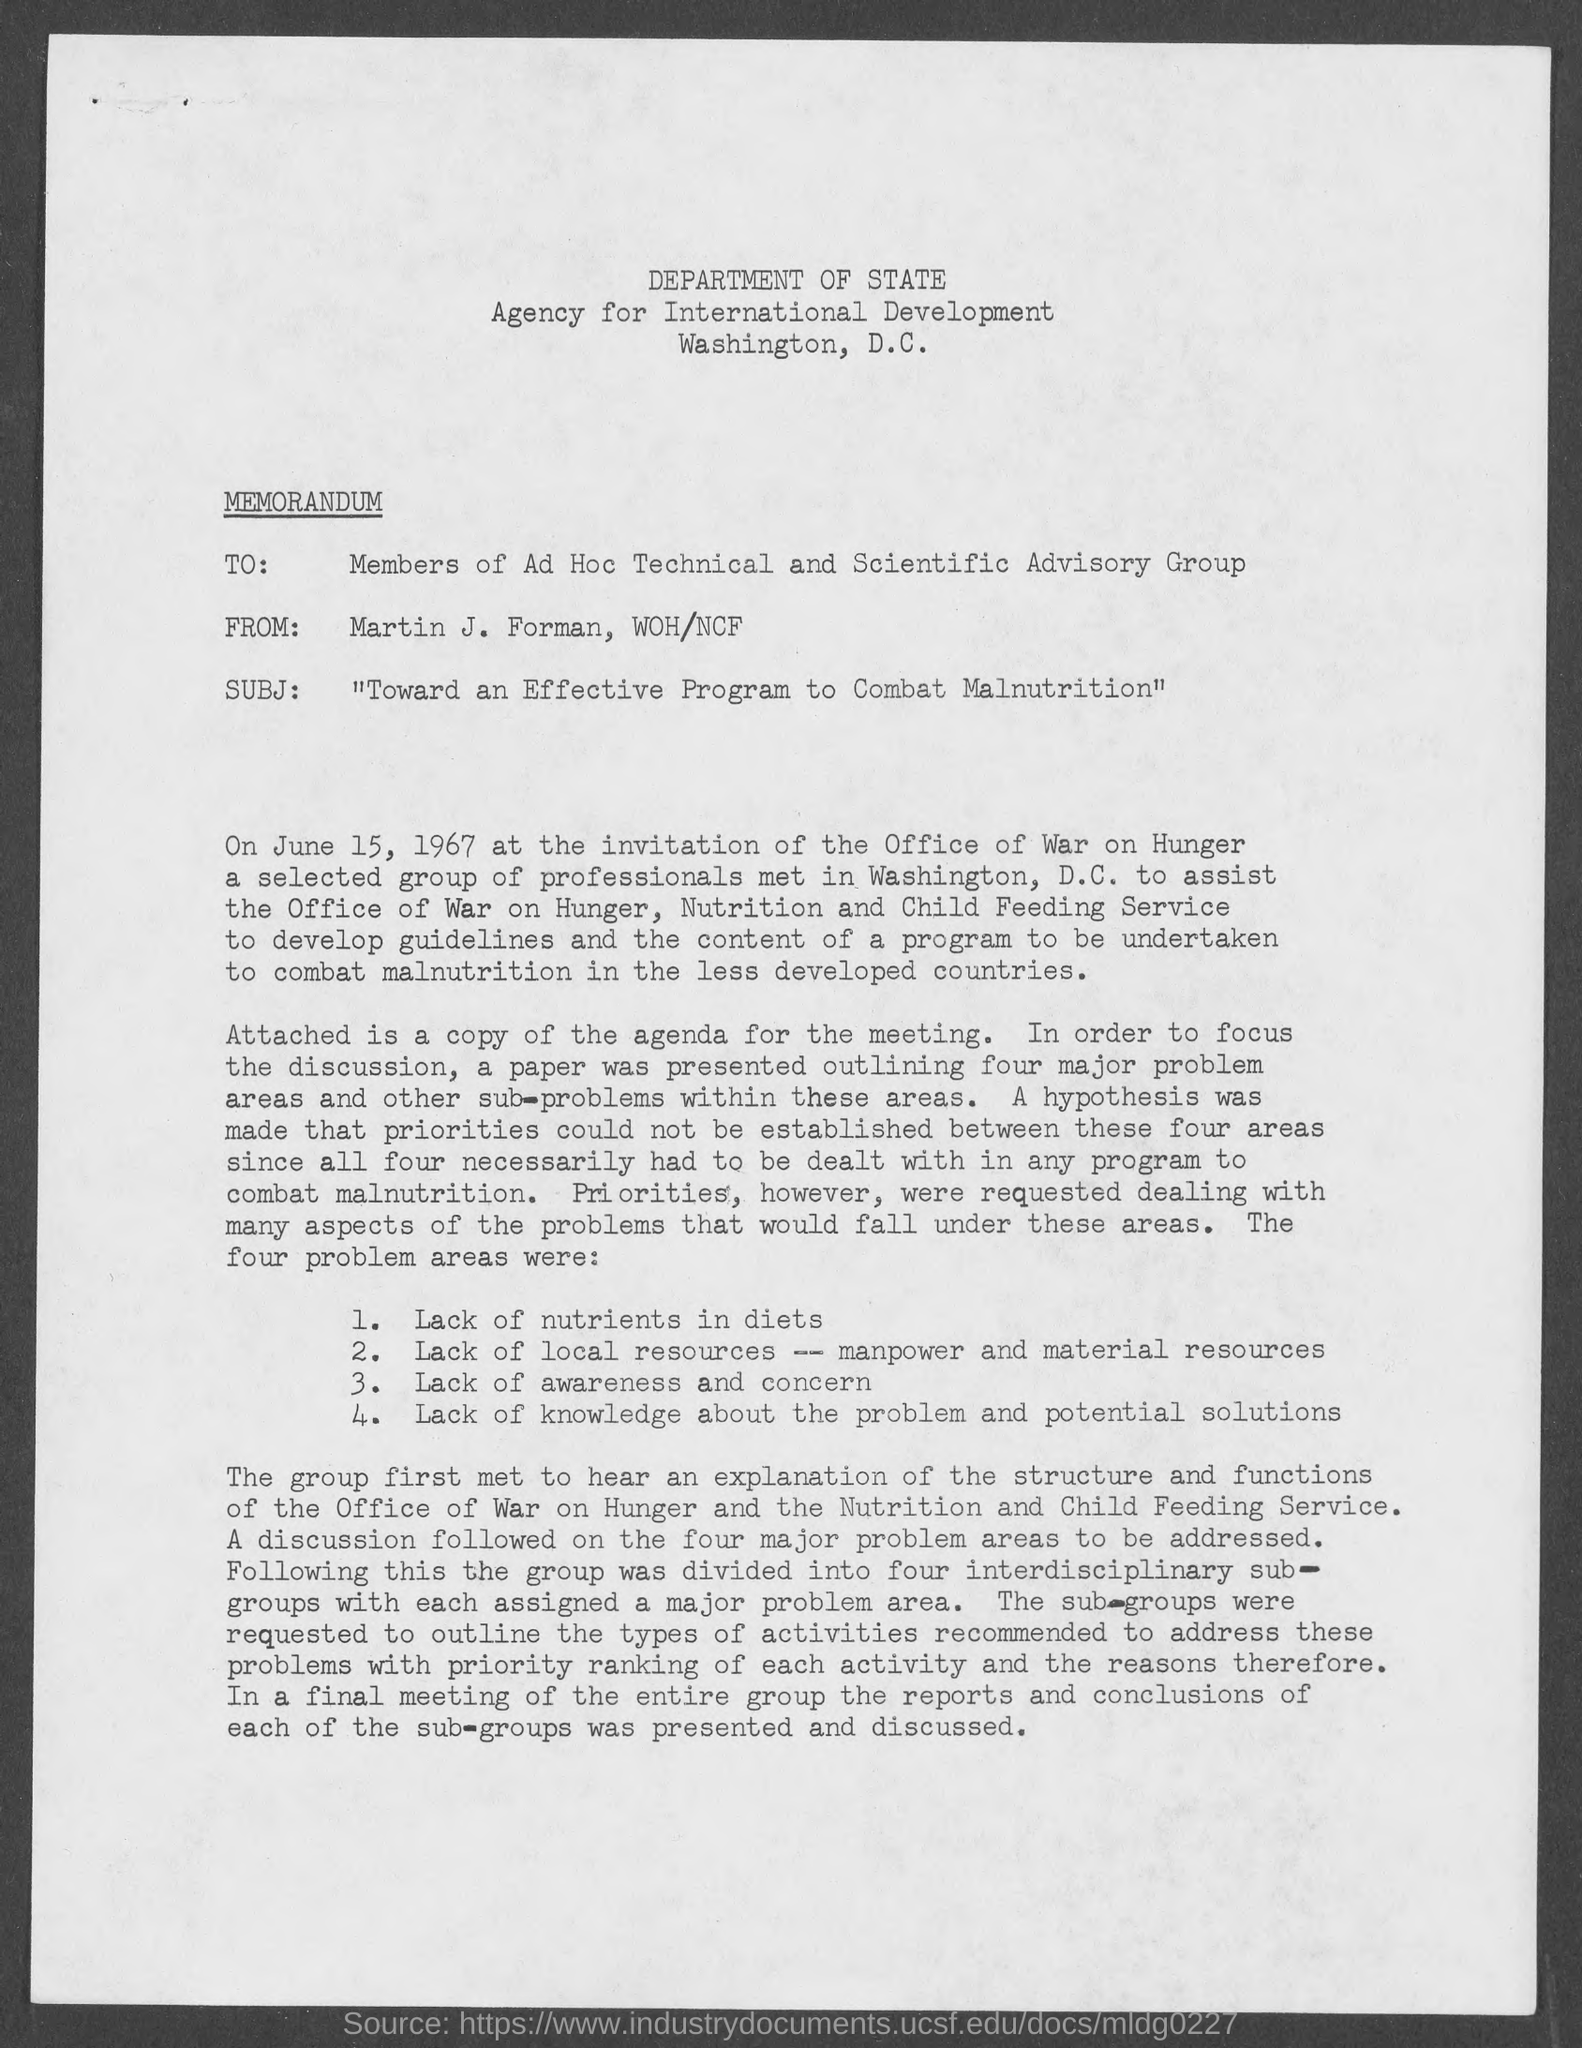Point out several critical features in this image. The sender of this memorandum is Martin J. Forman, and he is affiliated with WOH/NCF. This is a type of communication known as a memorandum. The recipient of this memorandum is the members of the ad hoc technical and scientific advisory group. The header of the document indicates that the DEPARTMENT OF STATE is mentioned. 